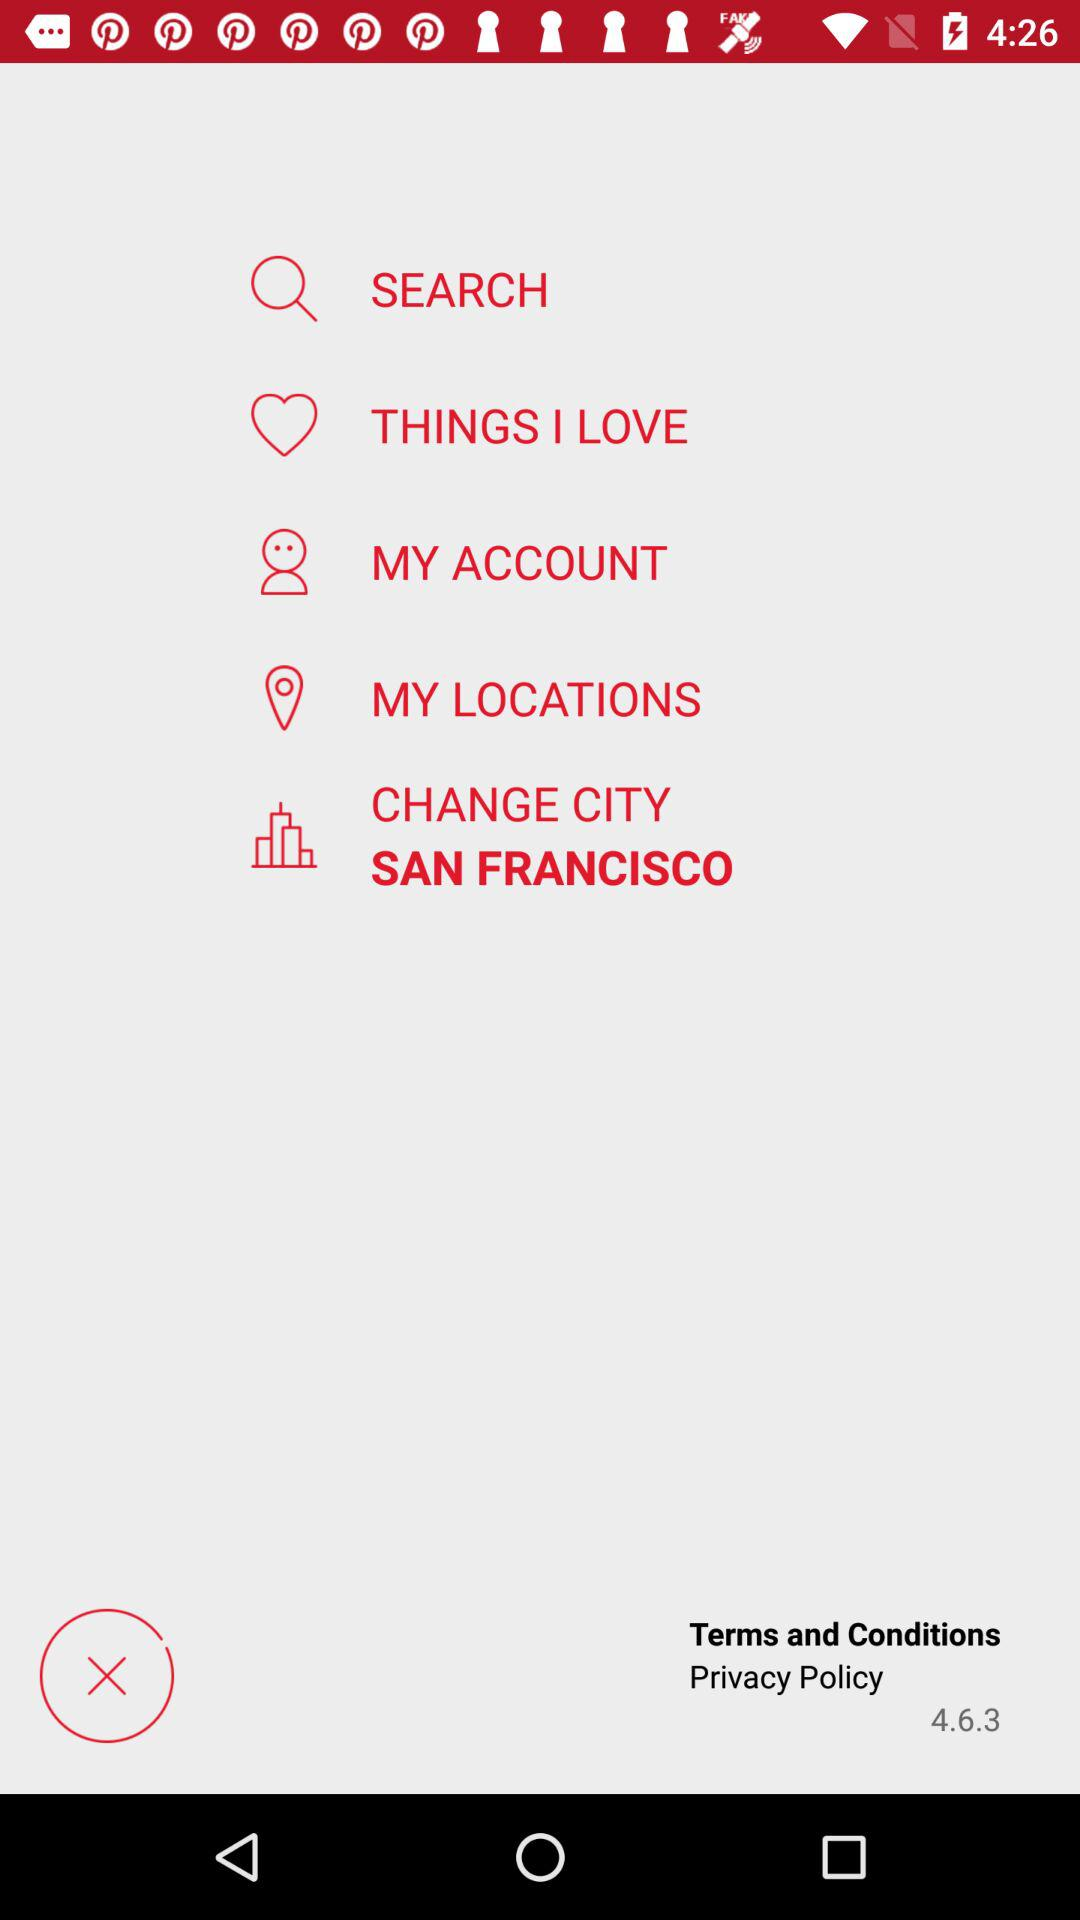Which language is used in Istanbul? The language used in Istanbul is English. 